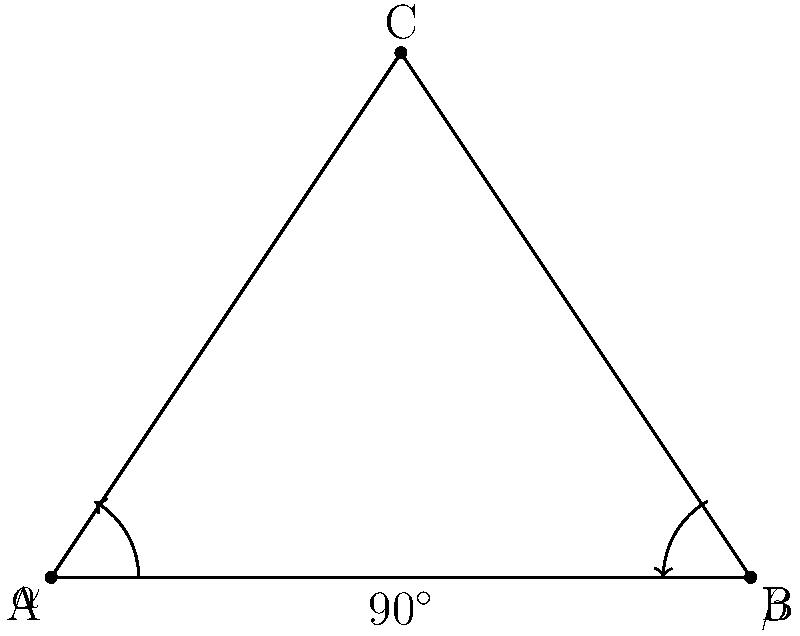In a library, a children's book is opened to form an isosceles triangle with the cover and pages. If the angle between the cover and the table is $\alpha$ and the angle between the last page and the table is $\beta$, what is the relationship between $\alpha$ and $\beta$? Let's approach this step-by-step:

1) In an isosceles triangle, the base angles are equal. Here, $\alpha$ and $\beta$ are the base angles.

2) In any triangle, the sum of all angles is always 180°.

3) We can see that the angle at the top of the triangle (where the spine of the book is) is 90° or a right angle. This is because when a book is fully closed, its covers form a right angle.

4) So, we can write an equation:
   $\alpha + \beta + 90^\circ = 180^\circ$

5) Simplifying:
   $\alpha + \beta = 90^\circ$

6) Since the triangle is isosceles and $\alpha$ and $\beta$ are the base angles, they must be equal:
   $\alpha = \beta$

7) Substituting this into our equation:
   $\alpha + \alpha = 90^\circ$
   $2\alpha = 90^\circ$
   $\alpha = 45^\circ$

8) Therefore, $\beta$ must also equal 45°.

Thus, we can conclude that $\alpha = \beta = 45^\circ$.
Answer: $\alpha = \beta = 45^\circ$ 